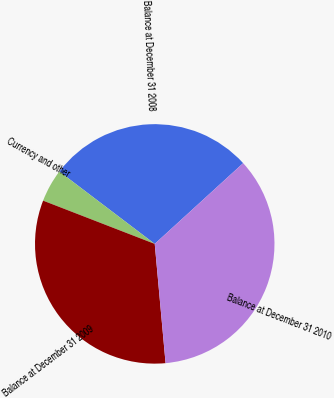Convert chart. <chart><loc_0><loc_0><loc_500><loc_500><pie_chart><fcel>Balance at December 31 2008<fcel>Currency and other<fcel>Balance at December 31 2009<fcel>Balance at December 31 2010<nl><fcel>27.89%<fcel>4.45%<fcel>32.33%<fcel>35.34%<nl></chart> 